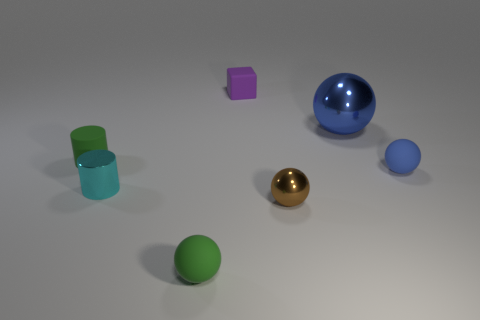If I were to arrange these objects from largest to smallest based on volume, what would that order be? Arranging the objects from largest to smallest based on volume, we would likely start with the largest blue sphere, followed by the green cylinder, the smaller blue sphere, the golden sphere, and finally the smallest, the purple cube. This estimation assumes that all objects are solid and utilizes visible size and geometric formulas to approximate volume. 